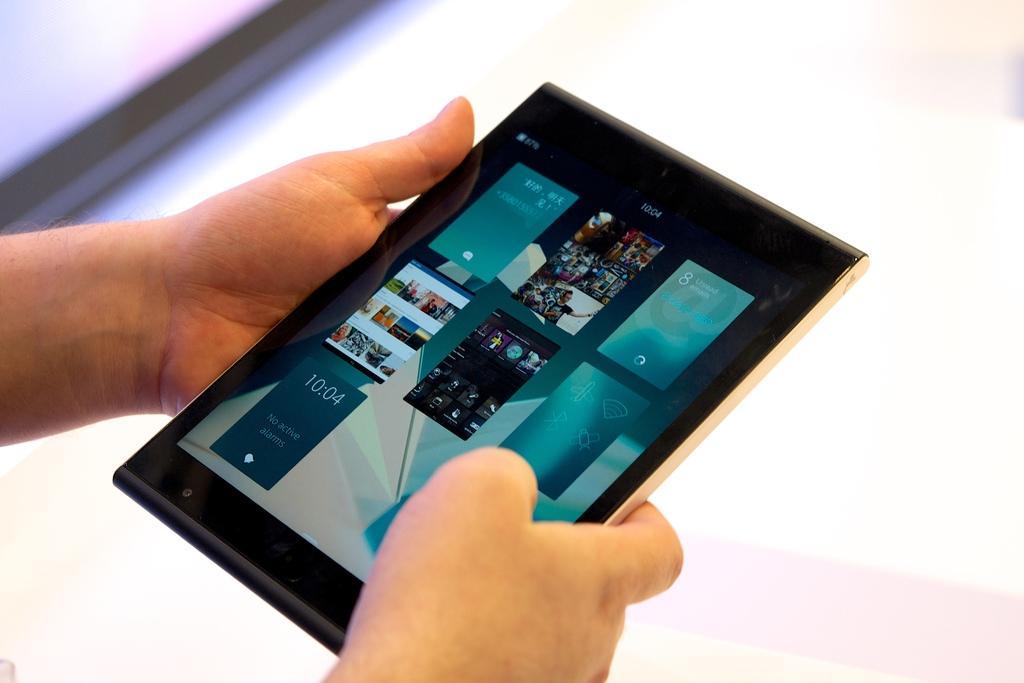Could you give a brief overview of what you see in this image? In this image there is a person who is holding the tablet with both the hands. 